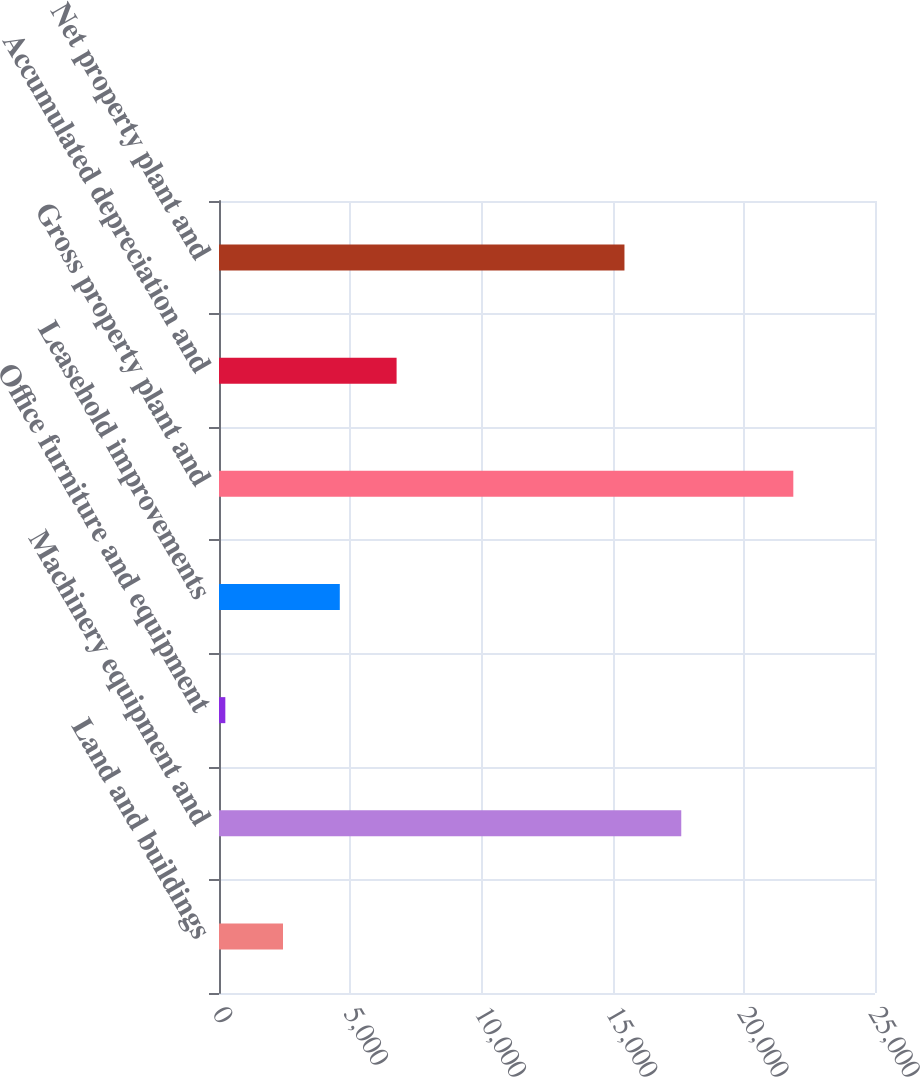Convert chart. <chart><loc_0><loc_0><loc_500><loc_500><bar_chart><fcel>Land and buildings<fcel>Machinery equipment and<fcel>Office furniture and equipment<fcel>Leasehold improvements<fcel>Gross property plant and<fcel>Accumulated depreciation and<fcel>Net property plant and<nl><fcel>2439<fcel>17616.6<fcel>241<fcel>4603.6<fcel>21887<fcel>6768.2<fcel>15452<nl></chart> 